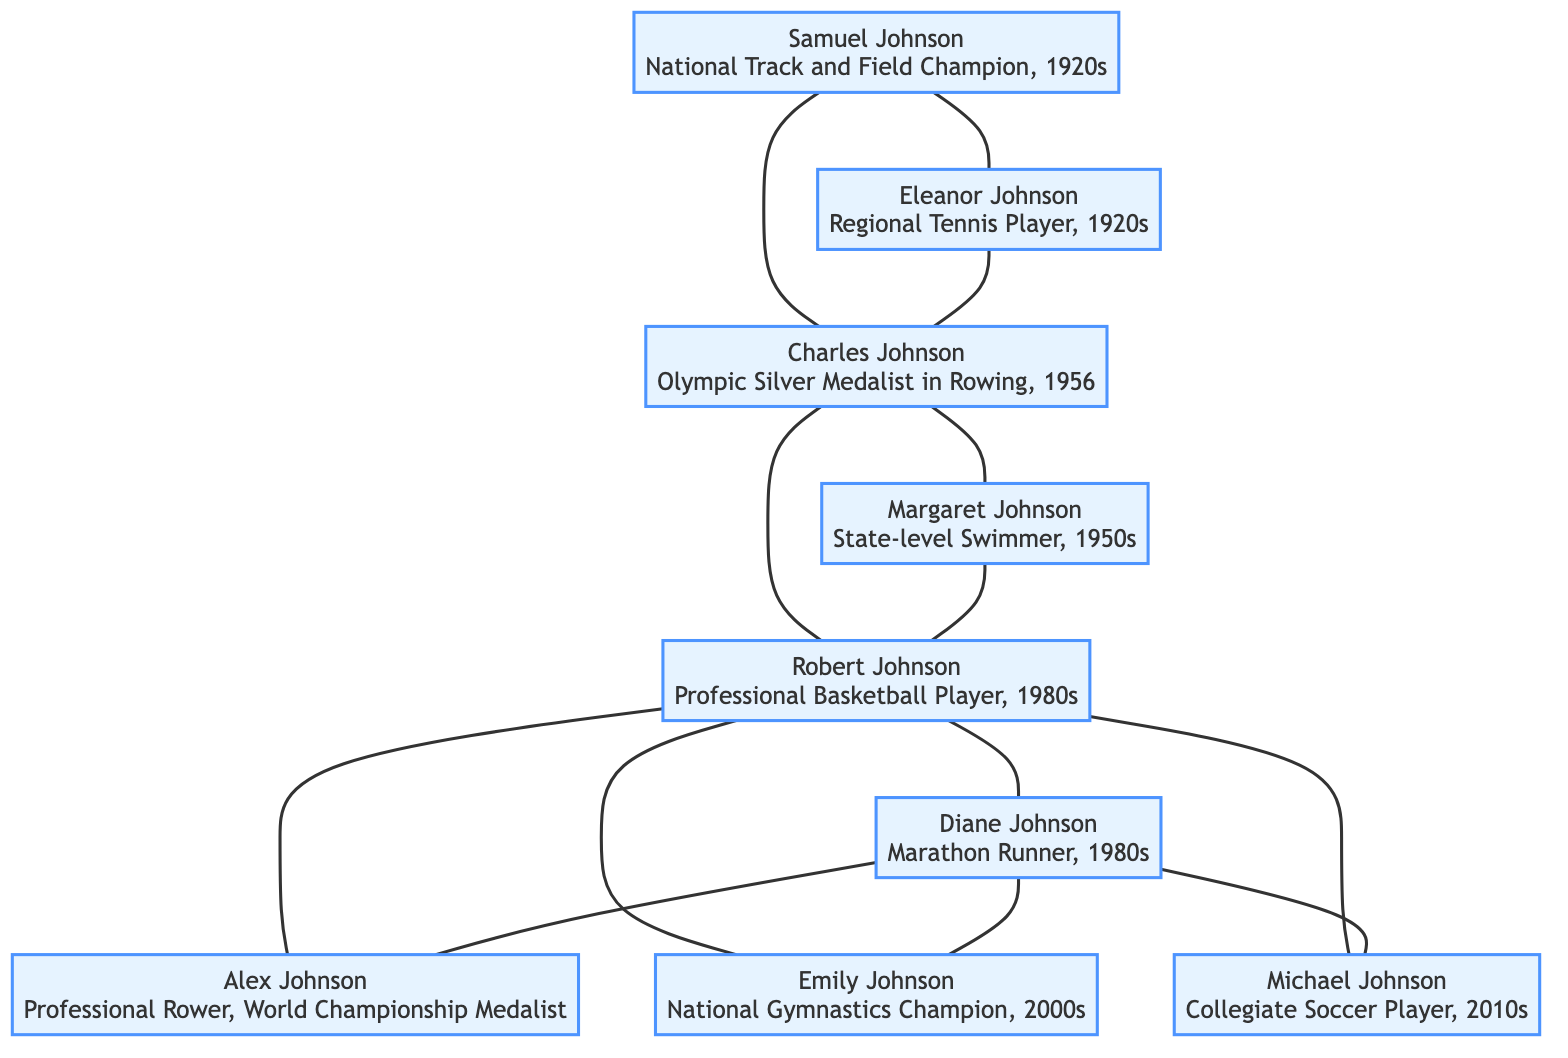What is the achievement of Charles Johnson? Charles Johnson is noted in the diagram as an Olympic Silver Medalist in Rowing, specifically in the year 1956.
Answer: Olympic Silver Medalist in Rowing, 1956 Who are the siblings of Alex Johnson? According to the diagram, Alex Johnson has two siblings mentioned, which are Emily Johnson and Michael Johnson. The diagram clearly connects them under the same parent node.
Answer: Emily Johnson and Michael Johnson How many nodes are there in the family tree? The family tree diagram consists of several distinct nodes representing individuals and their achievements. Upon counting, there are 9 total nodes in the diagram.
Answer: 9 Which athlete achieved a national championship in gymnastics? The diagram indicates that Emily Johnson achieved a national championship in gymnastics, specifically in the 2000s.
Answer: National Gymnastics Champion, 2000s What is the relationship between Robert Johnson and Alex Johnson? The diagram shows a direct connection where Robert Johnson is the parent of Alex Johnson, creating a familial relationship as father to son.
Answer: Father Who was a marathon runner in the 1980s? In the family tree, Diane Johnson is explicitly noted as a marathon runner during the 1980s, making her the identified athlete for that era.
Answer: Marathon Runner, 1980s What is the achievement of Samuel Johnson? Samuel Johnson is recognized in the diagram for being a National Track and Field Champion, which occurred during the 1920s.
Answer: National Track and Field Champion, 1920s How many athletes in the family tree were active in the 1980s? By reviewing the diagram, there are two individuals listed—Robert Johnson and Diane Johnson—who are identified as athletes active during the 1980s.
Answer: 2 What is the relationship between Eleanor Johnson and Charles Johnson? Eleanor Johnson is connected to Samuel Johnson as his spouse, and Charles Johnson is their child, indicating a mother-son relationship between Eleanor and Charles.
Answer: Mother-son relationship 